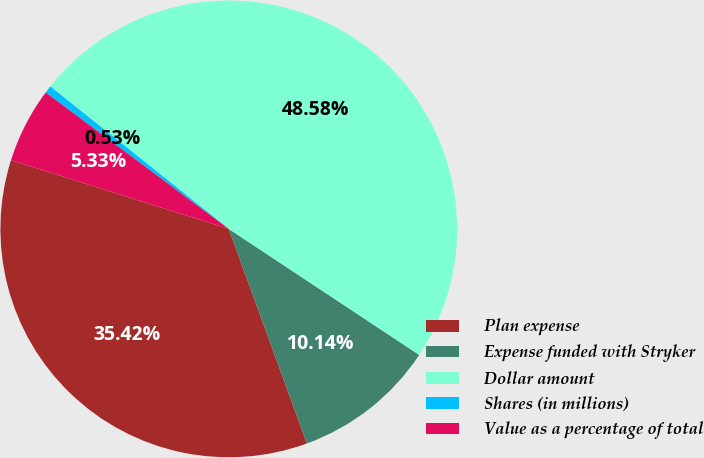<chart> <loc_0><loc_0><loc_500><loc_500><pie_chart><fcel>Plan expense<fcel>Expense funded with Stryker<fcel>Dollar amount<fcel>Shares (in millions)<fcel>Value as a percentage of total<nl><fcel>35.42%<fcel>10.14%<fcel>48.58%<fcel>0.53%<fcel>5.33%<nl></chart> 